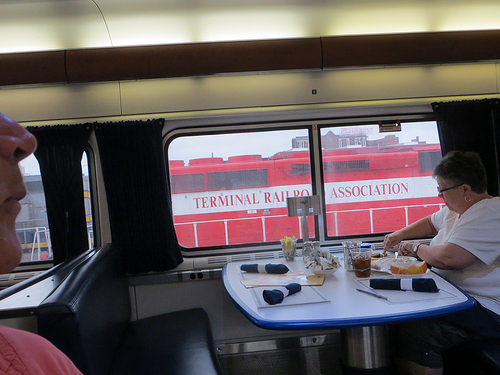<image>
Is there a bread on the napkin? No. The bread is not positioned on the napkin. They may be near each other, but the bread is not supported by or resting on top of the napkin. 